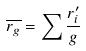<formula> <loc_0><loc_0><loc_500><loc_500>\overline { r _ { g } } = \sum \frac { r _ { i } ^ { \prime } } { g }</formula> 